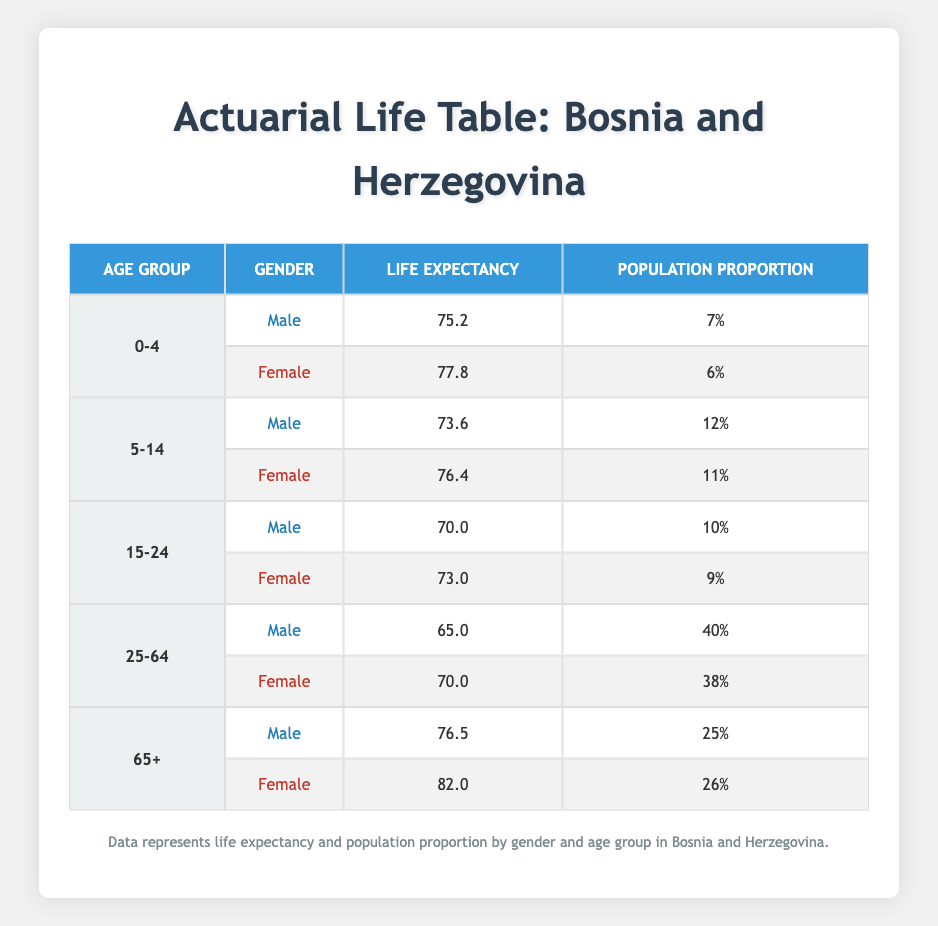What is the life expectancy for males aged 0-4 in Bosnia and Herzegovina? The table shows that the life expectancy for males in the age group 0-4 is 75.2 years.
Answer: 75.2 What is the population proportion of females aged 65+? According to the table, the population proportion of females aged 65+ is 26%.
Answer: 26% Do females have a higher life expectancy than males in the 25-64 age group? In the 25-64 age group, females have a life expectancy of 70.0 years, while males have a life expectancy of 65.0 years. Since 70.0 > 65.0, the statement is true.
Answer: Yes What is the average life expectancy for males across all age groups listed? The life expectancies for males in the age groups are 75.2, 73.6, 70.0, 65.0, and 76.5. The average is calculated as (75.2 + 73.6 + 70.0 + 65.0 + 76.5) / 5 = 66.86.
Answer: 66.86 Is the life expectancy for females aged 15-24 higher than that for females aged 5-14? For females aged 15-24, the life expectancy is 73.0 years and for ages 5-14, it is 76.4 years. Since 73.0 < 76.4, the statement is false.
Answer: No What age group has the highest life expectancy for females? By examining the life expactancies, females aged 65+ have the highest life expectancy at 82.0 years.
Answer: 82.0 How many male age groups have a life expectancy below 70 years? The male age groups with a life expectancy below 70 years are 15-24 (70.0) and 25-64 (65.0). Thus, there are two age groups.
Answer: 2 What is the difference in life expectancy between female and male in the 0-4 age group? The difference is calculated by subtracting the male life expectancy (75.2) from the female life expectancy (77.8), which gives 77.8 - 75.2 = 2.6 years.
Answer: 2.6 Does the male population proportion in the 25-64 age group exceed 40%? The male population proportion in the 25-64 age group is 40%. Therefore, since it is equal and not exceeding, the answer is false.
Answer: No 